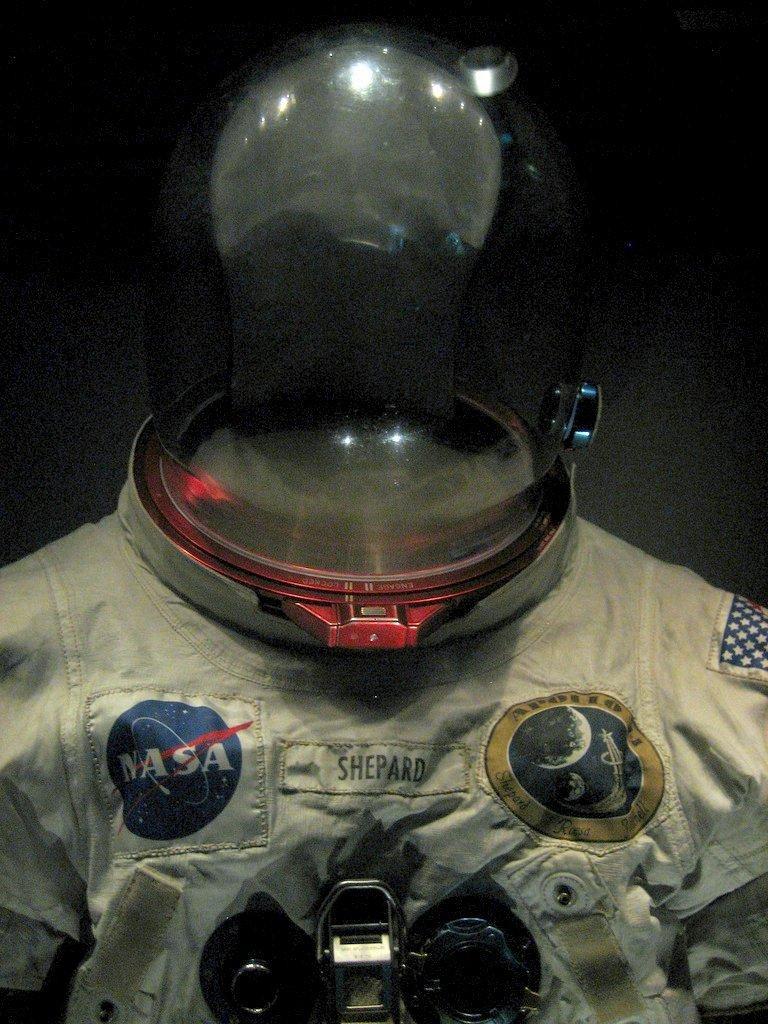In one or two sentences, can you explain what this image depicts? In this image there is an astronaut suit. There is text on the suit. On the top there is a helmet. The background is dark. 